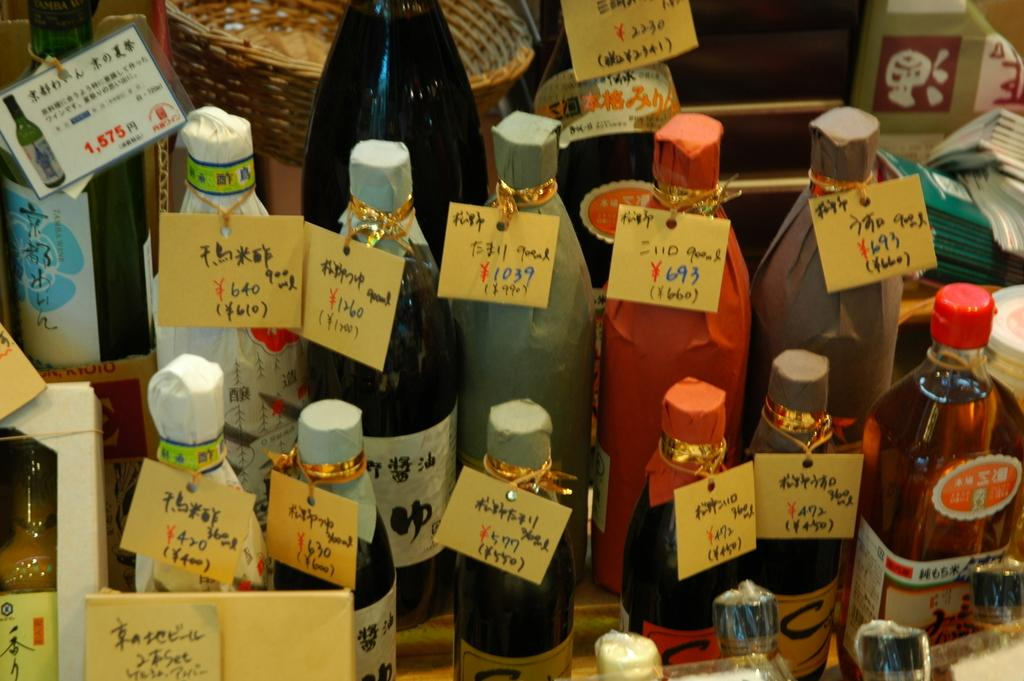What is the main subject of the image? The main subject of the image is many bottles. What distinguishes each bottle from the others? Each bottle has a tag attached to it. What information can be found on the tags? The tags contain the price of the bottle. What type of brush is being used by the secretary in the image? There is no secretary or brush present in the image; it only features bottles with tags. 